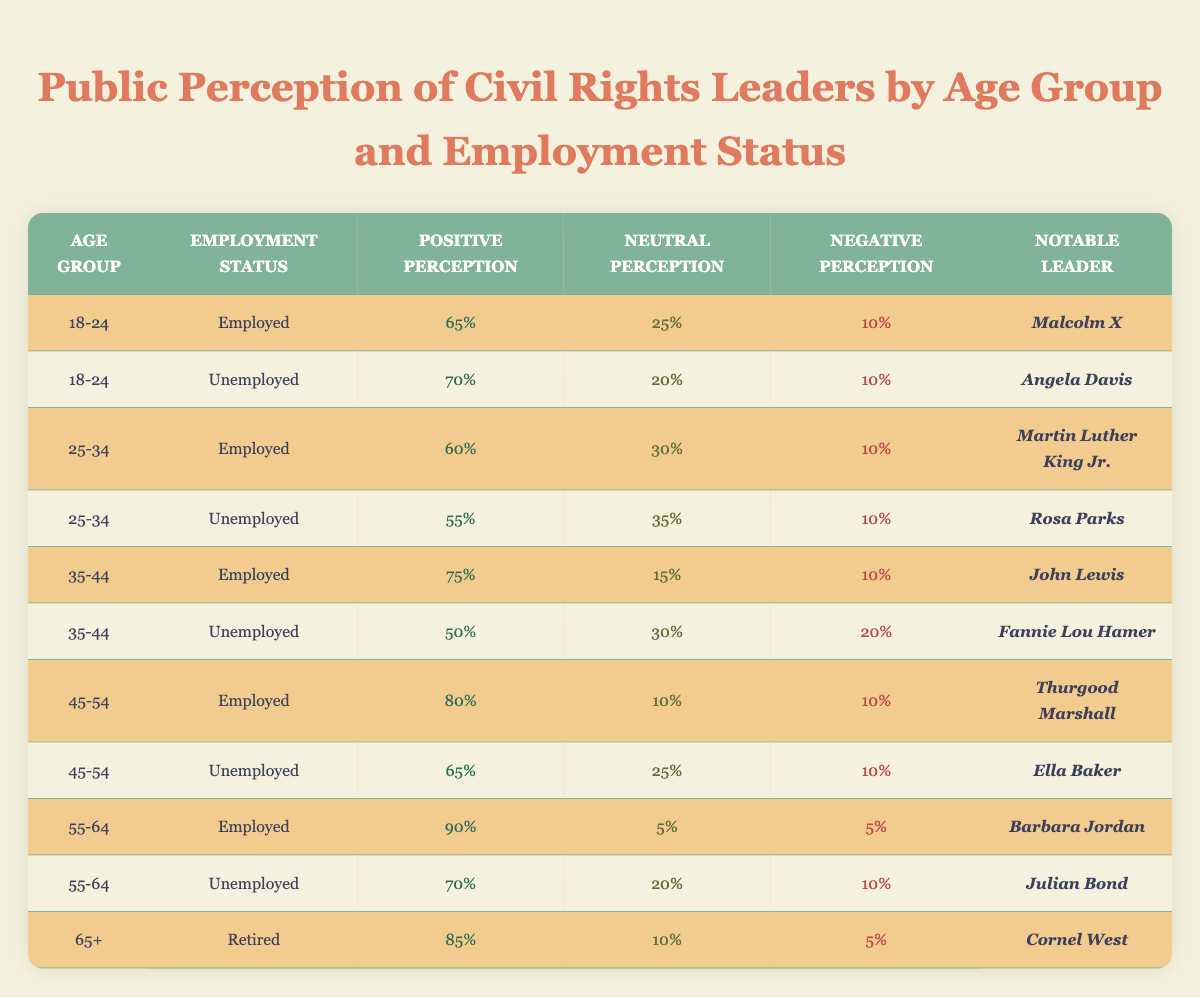What is the positive perception percentage of the unemployed individuals in the 18-24 age group? The table clearly shows that for the 18-24 age group with an unemployed status, the positive perception percentage is 70%.
Answer: 70% Which notable leader has the highest positive perception in the age group 45-54? Referring to the table, Thurgood Marshall has an 80% positive perception, which is the highest among the notable leaders listed in the 45-54 age group.
Answer: Thurgood Marshall What is the average positive perception for employed individuals across all age groups? The positive perception percentages for employed individuals are 65%, 60%, 75%, 80%, and 90%. Adding these gives 65 + 60 + 75 + 80 + 90 = 370, and dividing by 5 (for the 5 age groups) results in an average of 370/5 = 74%.
Answer: 74% Is it true that the negative perception percentage is the same for employed and unemployed individuals in the age group 25-34? The table shows that the negative perception for employed individuals (25-34) is 10%, while for unemployed individuals in the same age group it is also listed as 10%. Therefore, it is true that they are the same.
Answer: True Among the unemployed in the 35-44 age group, which leader has the lowest positive perception? In the 35-44 age group, Fannie Lou Hamer is listed as having a positive perception of 50%, which is lower than any other leader for unemployed individuals in that age group.
Answer: Fannie Lou Hamer What percentage of the 55-64 age group is neutral in perception when employed? For the 55-64 age group, the employed individuals have a neutral perception percentage of 5%, as indicated in the table.
Answer: 5% Which age group has the highest negative perception overall? First, we examine the negative perception percentages: 10% (18-24), 10% (25-34), 10% (35-44), 10% (45-54), 5% (55-64), and 20% (35-44). The highest negative perception is 20% for unemployed individuals aged 35-44.
Answer: 35-44 What is the difference between the positive perception percentage of employed individuals aged 55-64 and unemployed individuals aged 55-64? From the table, the positive perception for employed individuals aged 55-64 is 90%, while for the unemployed in that same age group it is 70%. The difference is 90 - 70 = 20%.
Answer: 20% 